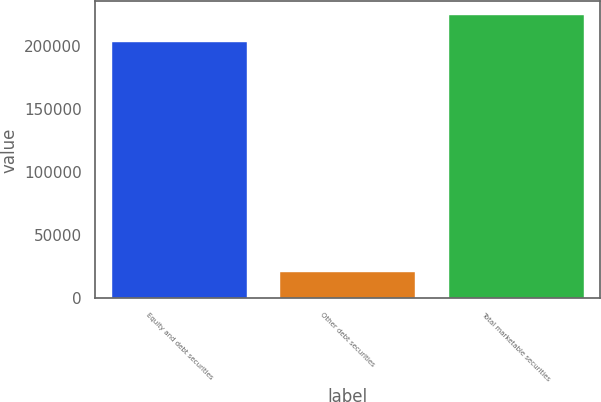Convert chart to OTSL. <chart><loc_0><loc_0><loc_500><loc_500><bar_chart><fcel>Equity and debt securities<fcel>Other debt securities<fcel>Total marketable securities<nl><fcel>203091<fcel>21360<fcel>224451<nl></chart> 